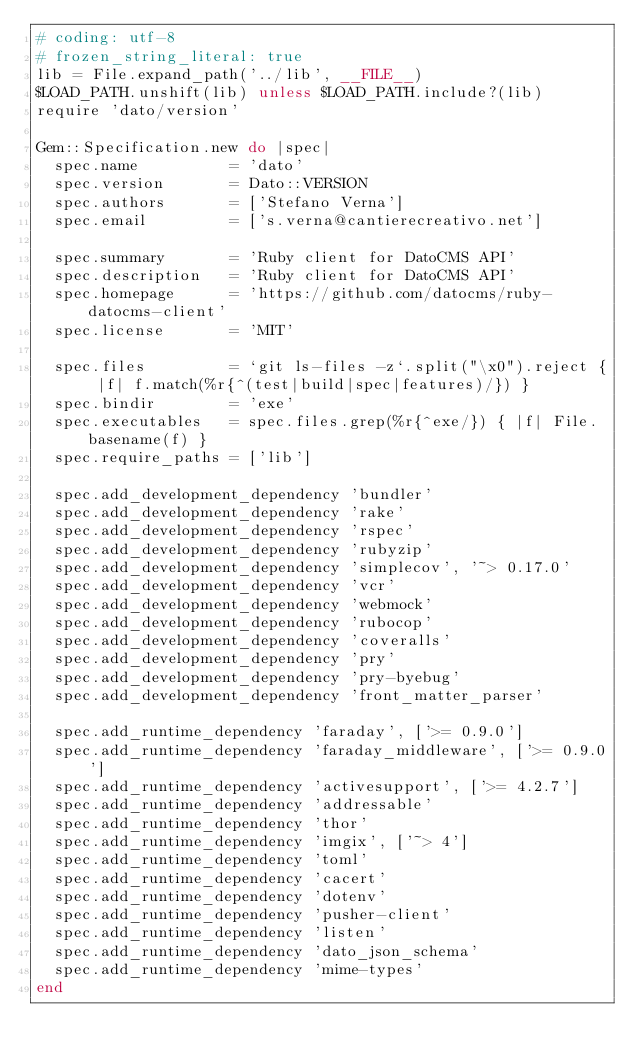Convert code to text. <code><loc_0><loc_0><loc_500><loc_500><_Ruby_># coding: utf-8
# frozen_string_literal: true
lib = File.expand_path('../lib', __FILE__)
$LOAD_PATH.unshift(lib) unless $LOAD_PATH.include?(lib)
require 'dato/version'

Gem::Specification.new do |spec|
  spec.name          = 'dato'
  spec.version       = Dato::VERSION
  spec.authors       = ['Stefano Verna']
  spec.email         = ['s.verna@cantierecreativo.net']

  spec.summary       = 'Ruby client for DatoCMS API'
  spec.description   = 'Ruby client for DatoCMS API'
  spec.homepage      = 'https://github.com/datocms/ruby-datocms-client'
  spec.license       = 'MIT'

  spec.files         = `git ls-files -z`.split("\x0").reject { |f| f.match(%r{^(test|build|spec|features)/}) }
  spec.bindir        = 'exe'
  spec.executables   = spec.files.grep(%r{^exe/}) { |f| File.basename(f) }
  spec.require_paths = ['lib']

  spec.add_development_dependency 'bundler'
  spec.add_development_dependency 'rake'
  spec.add_development_dependency 'rspec'
  spec.add_development_dependency 'rubyzip'
  spec.add_development_dependency 'simplecov', '~> 0.17.0'
  spec.add_development_dependency 'vcr'
  spec.add_development_dependency 'webmock'
  spec.add_development_dependency 'rubocop'
  spec.add_development_dependency 'coveralls'
  spec.add_development_dependency 'pry'
  spec.add_development_dependency 'pry-byebug'
  spec.add_development_dependency 'front_matter_parser'

  spec.add_runtime_dependency 'faraday', ['>= 0.9.0']
  spec.add_runtime_dependency 'faraday_middleware', ['>= 0.9.0']
  spec.add_runtime_dependency 'activesupport', ['>= 4.2.7']
  spec.add_runtime_dependency 'addressable'
  spec.add_runtime_dependency 'thor'
  spec.add_runtime_dependency 'imgix', ['~> 4']
  spec.add_runtime_dependency 'toml'
  spec.add_runtime_dependency 'cacert'
  spec.add_runtime_dependency 'dotenv'
  spec.add_runtime_dependency 'pusher-client'
  spec.add_runtime_dependency 'listen'
  spec.add_runtime_dependency 'dato_json_schema'
  spec.add_runtime_dependency 'mime-types'
end
</code> 